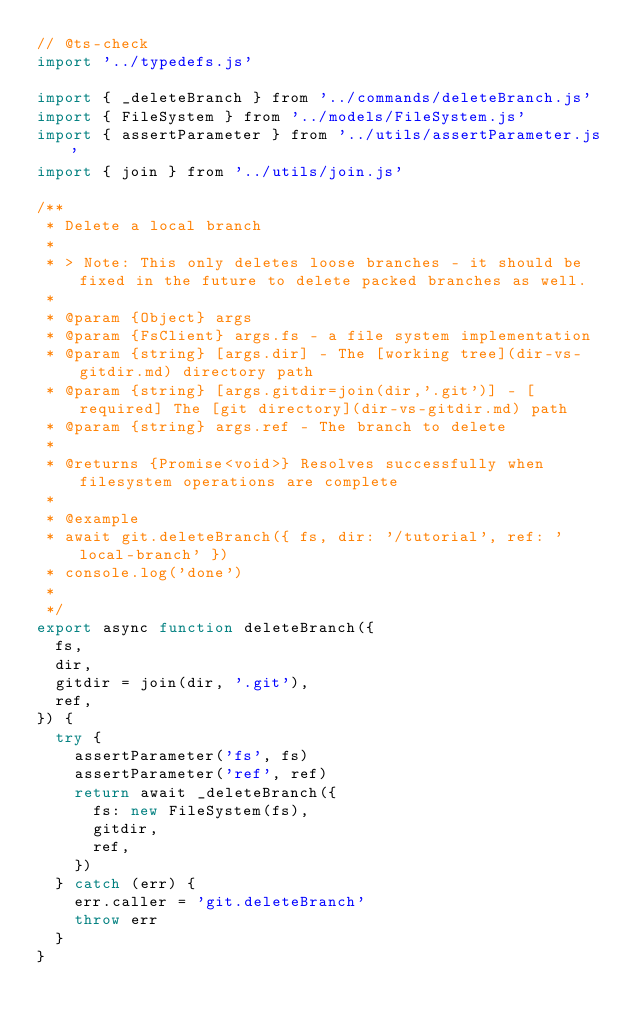<code> <loc_0><loc_0><loc_500><loc_500><_JavaScript_>// @ts-check
import '../typedefs.js'

import { _deleteBranch } from '../commands/deleteBranch.js'
import { FileSystem } from '../models/FileSystem.js'
import { assertParameter } from '../utils/assertParameter.js'
import { join } from '../utils/join.js'

/**
 * Delete a local branch
 *
 * > Note: This only deletes loose branches - it should be fixed in the future to delete packed branches as well.
 *
 * @param {Object} args
 * @param {FsClient} args.fs - a file system implementation
 * @param {string} [args.dir] - The [working tree](dir-vs-gitdir.md) directory path
 * @param {string} [args.gitdir=join(dir,'.git')] - [required] The [git directory](dir-vs-gitdir.md) path
 * @param {string} args.ref - The branch to delete
 *
 * @returns {Promise<void>} Resolves successfully when filesystem operations are complete
 *
 * @example
 * await git.deleteBranch({ fs, dir: '/tutorial', ref: 'local-branch' })
 * console.log('done')
 *
 */
export async function deleteBranch({
  fs,
  dir,
  gitdir = join(dir, '.git'),
  ref,
}) {
  try {
    assertParameter('fs', fs)
    assertParameter('ref', ref)
    return await _deleteBranch({
      fs: new FileSystem(fs),
      gitdir,
      ref,
    })
  } catch (err) {
    err.caller = 'git.deleteBranch'
    throw err
  }
}
</code> 